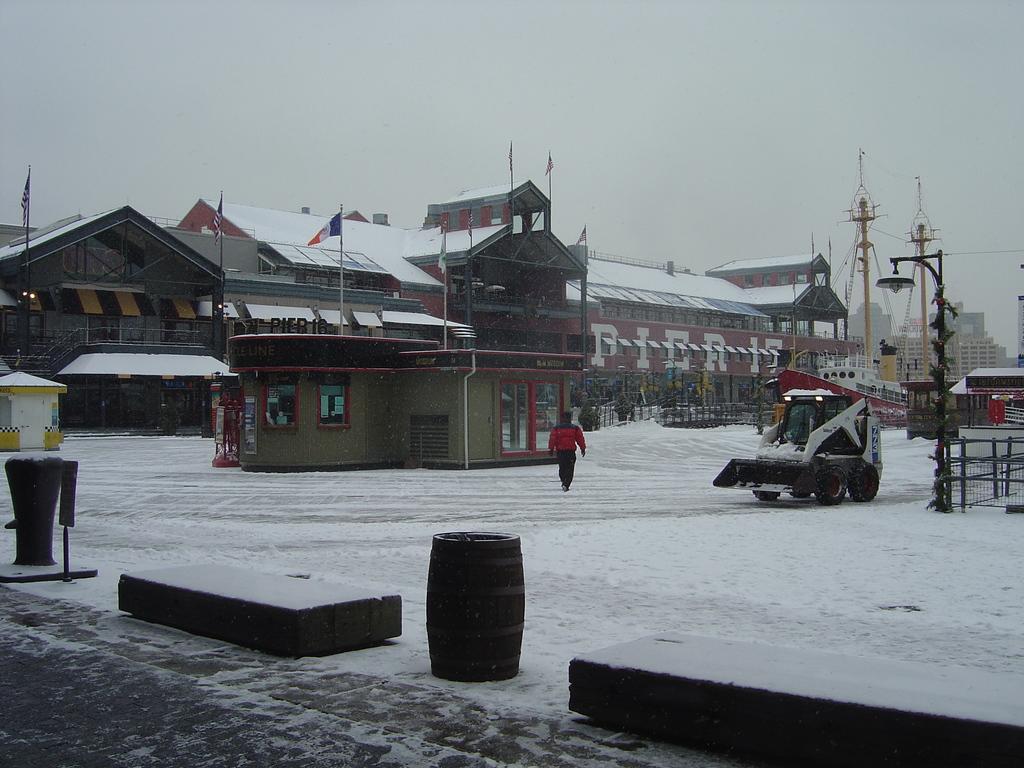Please provide a concise description of this image. In this image we can see buildings, flags, flag posts, cranes, street lights, street poles, person, motor vehicle, barrels, snow on the roads and sky. 